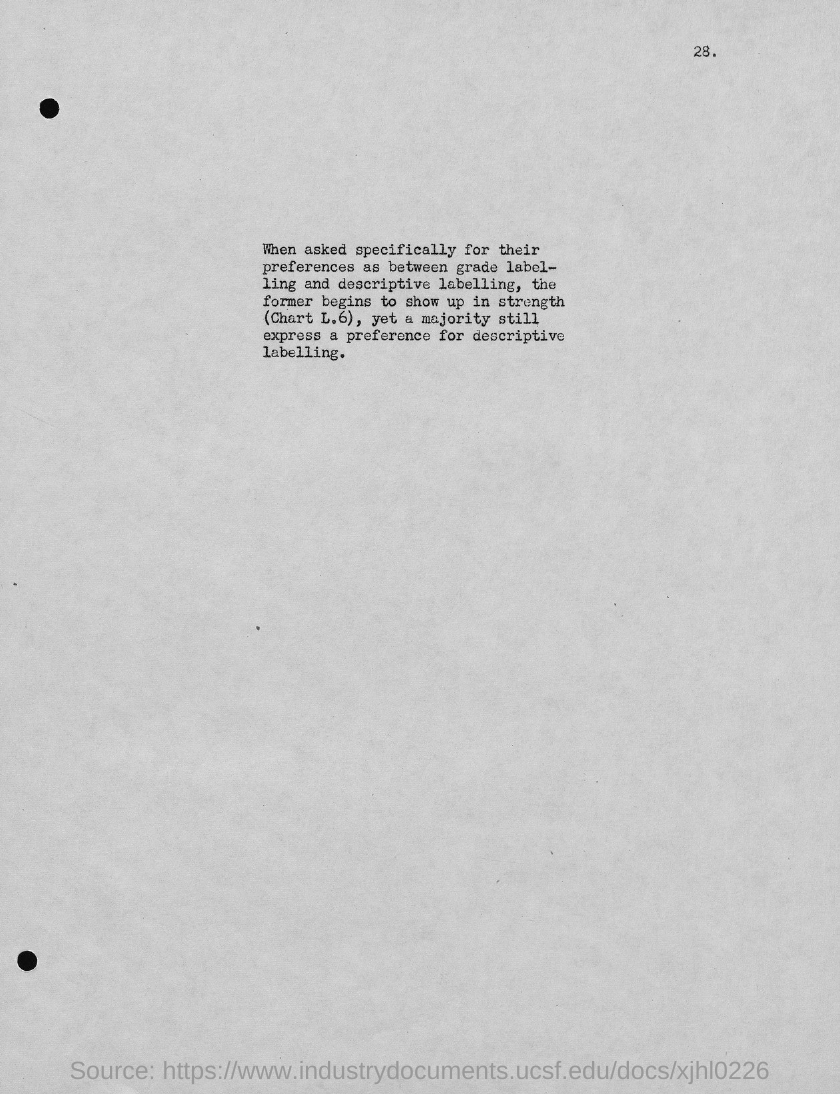What is the Page Number?
Ensure brevity in your answer.  28. 